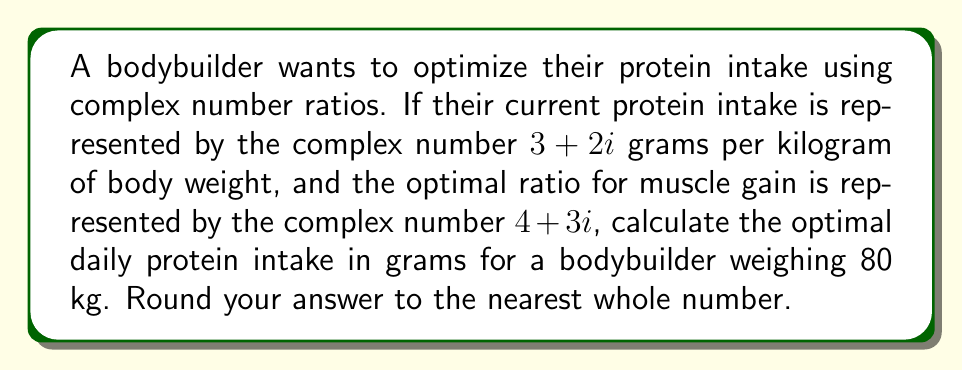Provide a solution to this math problem. Let's approach this step-by-step:

1) Current protein intake: $z_1 = 3 + 2i$ g/kg
   Optimal ratio: $z_2 = 4 + 3i$

2) To find the optimal intake, we need to multiply the current intake by the ratio of optimal to current:

   $z_{optimal} = z_1 \cdot \frac{z_2}{z_1}$

3) First, let's calculate $\frac{z_2}{z_1}$:
   
   $\frac{z_2}{z_1} = \frac{4 + 3i}{3 + 2i} \cdot \frac{3 - 2i}{3 - 2i}$

4) Simplify:
   
   $\frac{z_2}{z_1} = \frac{(4 + 3i)(3 - 2i)}{(3 + 2i)(3 - 2i)} = \frac{12 - 8i + 9i - 6i^2}{9 - 4i^2} = \frac{12 + i + 6}{13} = \frac{18 + i}{13}$

5) Now, multiply $z_1$ by this ratio:

   $z_{optimal} = (3 + 2i) \cdot (\frac{18 + i}{13})$

6) Distribute:
   
   $z_{optimal} = \frac{54 + 3i + 36i - 2}{13} = \frac{52 + 39i}{13} = 4 + 3i$ g/kg

7) For a bodybuilder weighing 80 kg, multiply by 80:

   $80 \cdot (4 + 3i) = 320 + 240i$ grams

8) The real part represents the actual protein intake in grams.
Answer: 320 grams 